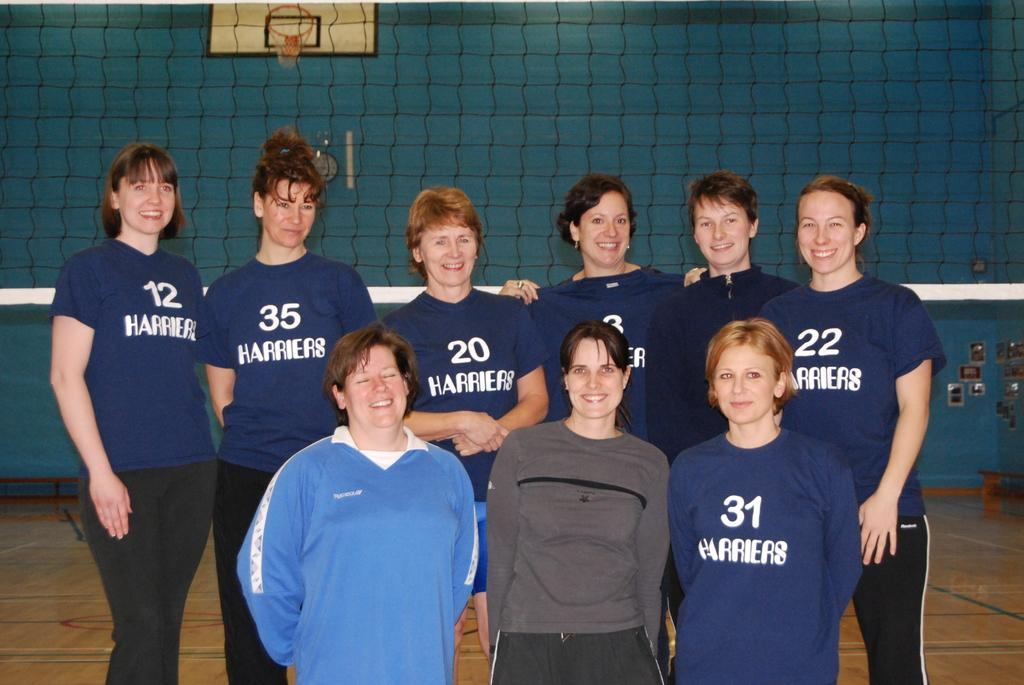<image>
Create a compact narrative representing the image presented. A group of women are on a team called Harriers. 